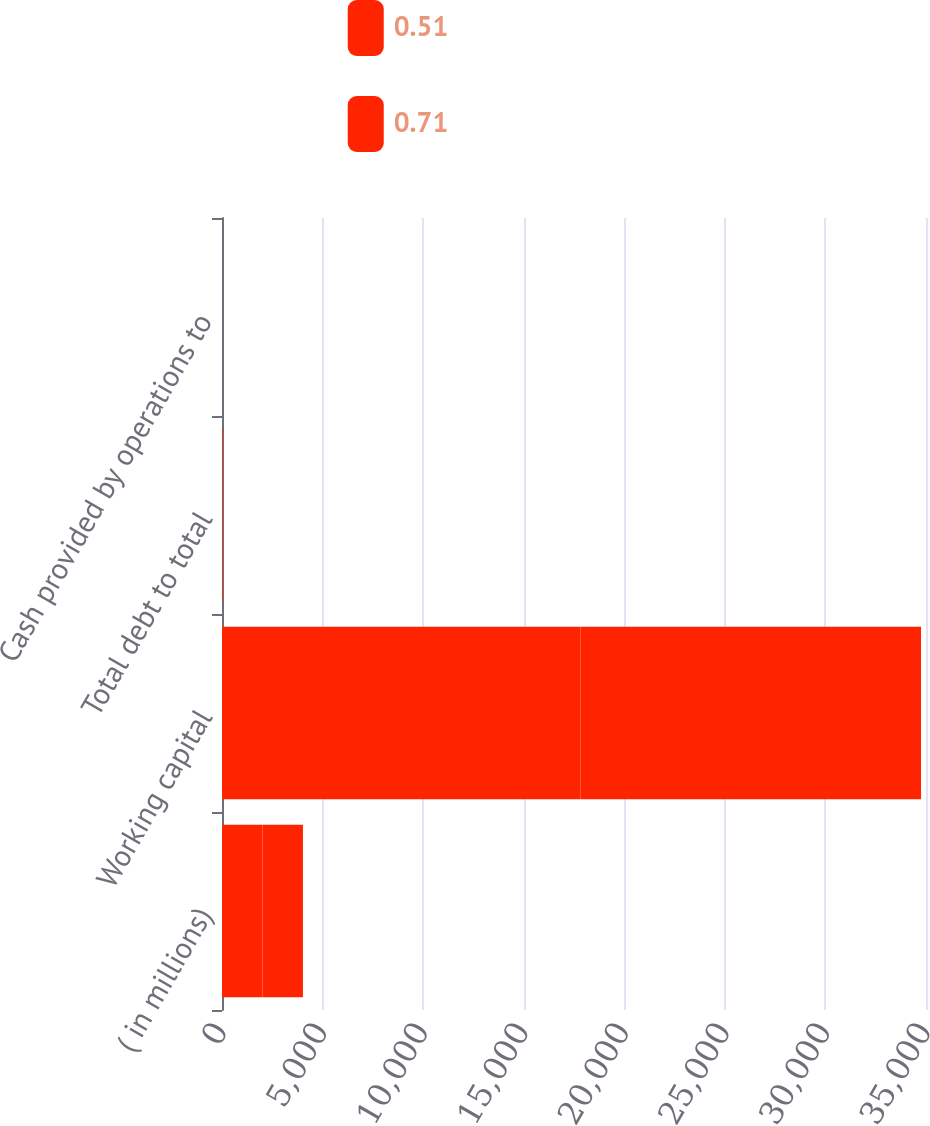Convert chart. <chart><loc_0><loc_0><loc_500><loc_500><stacked_bar_chart><ecel><fcel>( in millions)<fcel>Working capital<fcel>Total debt to total<fcel>Cash provided by operations to<nl><fcel>0.51<fcel>2013<fcel>17817<fcel>23.7<fcel>0.51<nl><fcel>0.71<fcel>2011<fcel>16936<fcel>16.7<fcel>0.71<nl></chart> 